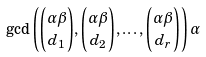<formula> <loc_0><loc_0><loc_500><loc_500>\gcd \left ( \binom { \alpha \beta } { d _ { 1 } } , \binom { \alpha \beta } { d _ { 2 } } , \dots , \binom { \alpha \beta } { d _ { r } } \right ) \alpha</formula> 